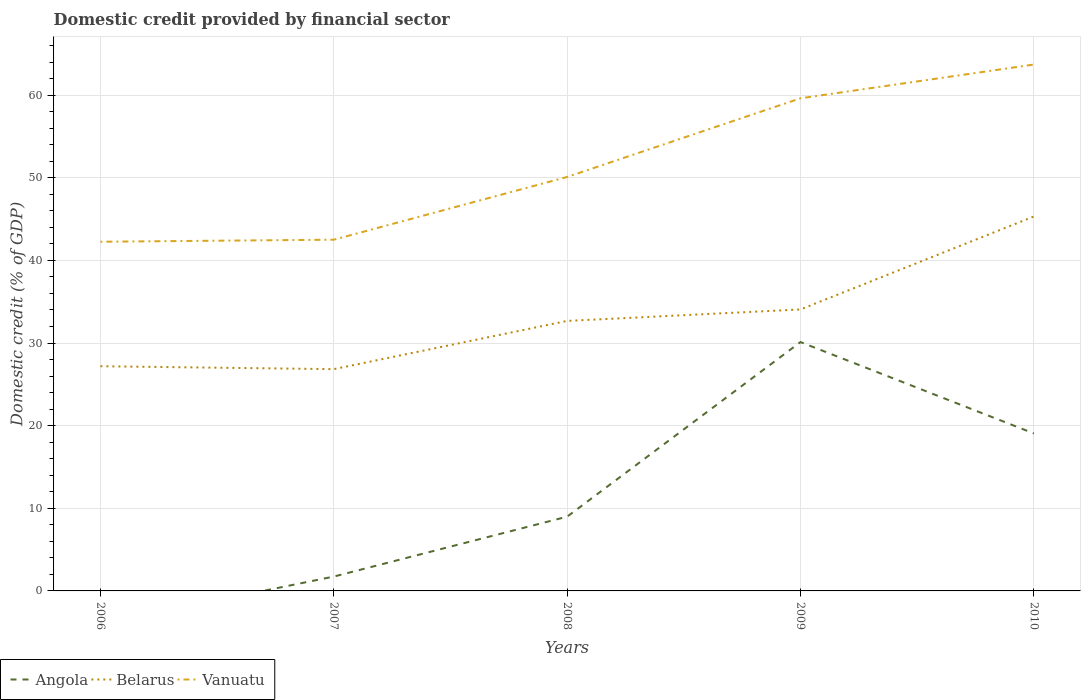How many different coloured lines are there?
Provide a short and direct response. 3. Does the line corresponding to Vanuatu intersect with the line corresponding to Belarus?
Your answer should be very brief. No. Is the number of lines equal to the number of legend labels?
Your answer should be compact. No. Across all years, what is the maximum domestic credit in Belarus?
Your answer should be compact. 26.84. What is the total domestic credit in Belarus in the graph?
Make the answer very short. -5.84. What is the difference between the highest and the second highest domestic credit in Vanuatu?
Keep it short and to the point. 21.44. How many years are there in the graph?
Ensure brevity in your answer.  5. Are the values on the major ticks of Y-axis written in scientific E-notation?
Provide a succinct answer. No. Does the graph contain grids?
Keep it short and to the point. Yes. Where does the legend appear in the graph?
Ensure brevity in your answer.  Bottom left. How many legend labels are there?
Your answer should be very brief. 3. How are the legend labels stacked?
Offer a very short reply. Horizontal. What is the title of the graph?
Offer a terse response. Domestic credit provided by financial sector. Does "OECD members" appear as one of the legend labels in the graph?
Ensure brevity in your answer.  No. What is the label or title of the Y-axis?
Offer a terse response. Domestic credit (% of GDP). What is the Domestic credit (% of GDP) in Belarus in 2006?
Offer a very short reply. 27.19. What is the Domestic credit (% of GDP) in Vanuatu in 2006?
Provide a succinct answer. 42.26. What is the Domestic credit (% of GDP) of Angola in 2007?
Your response must be concise. 1.74. What is the Domestic credit (% of GDP) in Belarus in 2007?
Ensure brevity in your answer.  26.84. What is the Domestic credit (% of GDP) in Vanuatu in 2007?
Your answer should be very brief. 42.5. What is the Domestic credit (% of GDP) in Angola in 2008?
Provide a short and direct response. 8.98. What is the Domestic credit (% of GDP) of Belarus in 2008?
Give a very brief answer. 32.67. What is the Domestic credit (% of GDP) in Vanuatu in 2008?
Provide a succinct answer. 50.09. What is the Domestic credit (% of GDP) in Angola in 2009?
Provide a succinct answer. 30.12. What is the Domestic credit (% of GDP) in Belarus in 2009?
Offer a very short reply. 34.06. What is the Domestic credit (% of GDP) in Vanuatu in 2009?
Your answer should be very brief. 59.61. What is the Domestic credit (% of GDP) in Angola in 2010?
Your answer should be compact. 19.06. What is the Domestic credit (% of GDP) of Belarus in 2010?
Offer a very short reply. 45.31. What is the Domestic credit (% of GDP) in Vanuatu in 2010?
Provide a succinct answer. 63.7. Across all years, what is the maximum Domestic credit (% of GDP) in Angola?
Provide a short and direct response. 30.12. Across all years, what is the maximum Domestic credit (% of GDP) in Belarus?
Give a very brief answer. 45.31. Across all years, what is the maximum Domestic credit (% of GDP) of Vanuatu?
Give a very brief answer. 63.7. Across all years, what is the minimum Domestic credit (% of GDP) in Angola?
Your response must be concise. 0. Across all years, what is the minimum Domestic credit (% of GDP) in Belarus?
Offer a terse response. 26.84. Across all years, what is the minimum Domestic credit (% of GDP) of Vanuatu?
Provide a short and direct response. 42.26. What is the total Domestic credit (% of GDP) in Angola in the graph?
Your response must be concise. 59.89. What is the total Domestic credit (% of GDP) of Belarus in the graph?
Ensure brevity in your answer.  166.08. What is the total Domestic credit (% of GDP) in Vanuatu in the graph?
Offer a terse response. 258.17. What is the difference between the Domestic credit (% of GDP) in Belarus in 2006 and that in 2007?
Provide a succinct answer. 0.35. What is the difference between the Domestic credit (% of GDP) of Vanuatu in 2006 and that in 2007?
Ensure brevity in your answer.  -0.25. What is the difference between the Domestic credit (% of GDP) of Belarus in 2006 and that in 2008?
Provide a succinct answer. -5.48. What is the difference between the Domestic credit (% of GDP) of Vanuatu in 2006 and that in 2008?
Ensure brevity in your answer.  -7.84. What is the difference between the Domestic credit (% of GDP) of Belarus in 2006 and that in 2009?
Your answer should be compact. -6.87. What is the difference between the Domestic credit (% of GDP) of Vanuatu in 2006 and that in 2009?
Offer a terse response. -17.36. What is the difference between the Domestic credit (% of GDP) in Belarus in 2006 and that in 2010?
Your response must be concise. -18.12. What is the difference between the Domestic credit (% of GDP) of Vanuatu in 2006 and that in 2010?
Your answer should be very brief. -21.44. What is the difference between the Domestic credit (% of GDP) in Angola in 2007 and that in 2008?
Your response must be concise. -7.25. What is the difference between the Domestic credit (% of GDP) in Belarus in 2007 and that in 2008?
Provide a succinct answer. -5.84. What is the difference between the Domestic credit (% of GDP) of Vanuatu in 2007 and that in 2008?
Make the answer very short. -7.59. What is the difference between the Domestic credit (% of GDP) in Angola in 2007 and that in 2009?
Ensure brevity in your answer.  -28.38. What is the difference between the Domestic credit (% of GDP) of Belarus in 2007 and that in 2009?
Your answer should be compact. -7.23. What is the difference between the Domestic credit (% of GDP) of Vanuatu in 2007 and that in 2009?
Offer a very short reply. -17.11. What is the difference between the Domestic credit (% of GDP) of Angola in 2007 and that in 2010?
Make the answer very short. -17.32. What is the difference between the Domestic credit (% of GDP) in Belarus in 2007 and that in 2010?
Ensure brevity in your answer.  -18.47. What is the difference between the Domestic credit (% of GDP) of Vanuatu in 2007 and that in 2010?
Your answer should be compact. -21.2. What is the difference between the Domestic credit (% of GDP) in Angola in 2008 and that in 2009?
Keep it short and to the point. -21.13. What is the difference between the Domestic credit (% of GDP) of Belarus in 2008 and that in 2009?
Ensure brevity in your answer.  -1.39. What is the difference between the Domestic credit (% of GDP) of Vanuatu in 2008 and that in 2009?
Ensure brevity in your answer.  -9.52. What is the difference between the Domestic credit (% of GDP) of Angola in 2008 and that in 2010?
Your response must be concise. -10.07. What is the difference between the Domestic credit (% of GDP) in Belarus in 2008 and that in 2010?
Offer a terse response. -12.64. What is the difference between the Domestic credit (% of GDP) in Vanuatu in 2008 and that in 2010?
Your response must be concise. -13.61. What is the difference between the Domestic credit (% of GDP) in Angola in 2009 and that in 2010?
Offer a terse response. 11.06. What is the difference between the Domestic credit (% of GDP) of Belarus in 2009 and that in 2010?
Provide a succinct answer. -11.25. What is the difference between the Domestic credit (% of GDP) of Vanuatu in 2009 and that in 2010?
Give a very brief answer. -4.09. What is the difference between the Domestic credit (% of GDP) of Belarus in 2006 and the Domestic credit (% of GDP) of Vanuatu in 2007?
Keep it short and to the point. -15.31. What is the difference between the Domestic credit (% of GDP) of Belarus in 2006 and the Domestic credit (% of GDP) of Vanuatu in 2008?
Keep it short and to the point. -22.9. What is the difference between the Domestic credit (% of GDP) of Belarus in 2006 and the Domestic credit (% of GDP) of Vanuatu in 2009?
Offer a very short reply. -32.42. What is the difference between the Domestic credit (% of GDP) of Belarus in 2006 and the Domestic credit (% of GDP) of Vanuatu in 2010?
Ensure brevity in your answer.  -36.51. What is the difference between the Domestic credit (% of GDP) of Angola in 2007 and the Domestic credit (% of GDP) of Belarus in 2008?
Provide a short and direct response. -30.94. What is the difference between the Domestic credit (% of GDP) of Angola in 2007 and the Domestic credit (% of GDP) of Vanuatu in 2008?
Make the answer very short. -48.36. What is the difference between the Domestic credit (% of GDP) of Belarus in 2007 and the Domestic credit (% of GDP) of Vanuatu in 2008?
Provide a short and direct response. -23.26. What is the difference between the Domestic credit (% of GDP) of Angola in 2007 and the Domestic credit (% of GDP) of Belarus in 2009?
Your response must be concise. -32.33. What is the difference between the Domestic credit (% of GDP) of Angola in 2007 and the Domestic credit (% of GDP) of Vanuatu in 2009?
Make the answer very short. -57.88. What is the difference between the Domestic credit (% of GDP) in Belarus in 2007 and the Domestic credit (% of GDP) in Vanuatu in 2009?
Your response must be concise. -32.78. What is the difference between the Domestic credit (% of GDP) of Angola in 2007 and the Domestic credit (% of GDP) of Belarus in 2010?
Ensure brevity in your answer.  -43.58. What is the difference between the Domestic credit (% of GDP) of Angola in 2007 and the Domestic credit (% of GDP) of Vanuatu in 2010?
Offer a terse response. -61.97. What is the difference between the Domestic credit (% of GDP) of Belarus in 2007 and the Domestic credit (% of GDP) of Vanuatu in 2010?
Provide a short and direct response. -36.86. What is the difference between the Domestic credit (% of GDP) in Angola in 2008 and the Domestic credit (% of GDP) in Belarus in 2009?
Your answer should be very brief. -25.08. What is the difference between the Domestic credit (% of GDP) in Angola in 2008 and the Domestic credit (% of GDP) in Vanuatu in 2009?
Your answer should be very brief. -50.63. What is the difference between the Domestic credit (% of GDP) of Belarus in 2008 and the Domestic credit (% of GDP) of Vanuatu in 2009?
Offer a terse response. -26.94. What is the difference between the Domestic credit (% of GDP) of Angola in 2008 and the Domestic credit (% of GDP) of Belarus in 2010?
Ensure brevity in your answer.  -36.33. What is the difference between the Domestic credit (% of GDP) in Angola in 2008 and the Domestic credit (% of GDP) in Vanuatu in 2010?
Your response must be concise. -54.72. What is the difference between the Domestic credit (% of GDP) of Belarus in 2008 and the Domestic credit (% of GDP) of Vanuatu in 2010?
Keep it short and to the point. -31.03. What is the difference between the Domestic credit (% of GDP) of Angola in 2009 and the Domestic credit (% of GDP) of Belarus in 2010?
Give a very brief answer. -15.2. What is the difference between the Domestic credit (% of GDP) of Angola in 2009 and the Domestic credit (% of GDP) of Vanuatu in 2010?
Make the answer very short. -33.58. What is the difference between the Domestic credit (% of GDP) in Belarus in 2009 and the Domestic credit (% of GDP) in Vanuatu in 2010?
Offer a terse response. -29.64. What is the average Domestic credit (% of GDP) of Angola per year?
Your answer should be compact. 11.98. What is the average Domestic credit (% of GDP) in Belarus per year?
Keep it short and to the point. 33.22. What is the average Domestic credit (% of GDP) in Vanuatu per year?
Give a very brief answer. 51.63. In the year 2006, what is the difference between the Domestic credit (% of GDP) of Belarus and Domestic credit (% of GDP) of Vanuatu?
Your answer should be compact. -15.07. In the year 2007, what is the difference between the Domestic credit (% of GDP) in Angola and Domestic credit (% of GDP) in Belarus?
Provide a short and direct response. -25.1. In the year 2007, what is the difference between the Domestic credit (% of GDP) in Angola and Domestic credit (% of GDP) in Vanuatu?
Provide a short and direct response. -40.77. In the year 2007, what is the difference between the Domestic credit (% of GDP) in Belarus and Domestic credit (% of GDP) in Vanuatu?
Ensure brevity in your answer.  -15.67. In the year 2008, what is the difference between the Domestic credit (% of GDP) in Angola and Domestic credit (% of GDP) in Belarus?
Your answer should be very brief. -23.69. In the year 2008, what is the difference between the Domestic credit (% of GDP) in Angola and Domestic credit (% of GDP) in Vanuatu?
Your response must be concise. -41.11. In the year 2008, what is the difference between the Domestic credit (% of GDP) of Belarus and Domestic credit (% of GDP) of Vanuatu?
Make the answer very short. -17.42. In the year 2009, what is the difference between the Domestic credit (% of GDP) of Angola and Domestic credit (% of GDP) of Belarus?
Keep it short and to the point. -3.95. In the year 2009, what is the difference between the Domestic credit (% of GDP) of Angola and Domestic credit (% of GDP) of Vanuatu?
Your answer should be compact. -29.5. In the year 2009, what is the difference between the Domestic credit (% of GDP) of Belarus and Domestic credit (% of GDP) of Vanuatu?
Your response must be concise. -25.55. In the year 2010, what is the difference between the Domestic credit (% of GDP) in Angola and Domestic credit (% of GDP) in Belarus?
Offer a very short reply. -26.25. In the year 2010, what is the difference between the Domestic credit (% of GDP) of Angola and Domestic credit (% of GDP) of Vanuatu?
Keep it short and to the point. -44.64. In the year 2010, what is the difference between the Domestic credit (% of GDP) in Belarus and Domestic credit (% of GDP) in Vanuatu?
Your answer should be very brief. -18.39. What is the ratio of the Domestic credit (% of GDP) of Belarus in 2006 to that in 2007?
Your answer should be very brief. 1.01. What is the ratio of the Domestic credit (% of GDP) in Belarus in 2006 to that in 2008?
Provide a short and direct response. 0.83. What is the ratio of the Domestic credit (% of GDP) of Vanuatu in 2006 to that in 2008?
Your response must be concise. 0.84. What is the ratio of the Domestic credit (% of GDP) in Belarus in 2006 to that in 2009?
Ensure brevity in your answer.  0.8. What is the ratio of the Domestic credit (% of GDP) of Vanuatu in 2006 to that in 2009?
Your answer should be compact. 0.71. What is the ratio of the Domestic credit (% of GDP) of Belarus in 2006 to that in 2010?
Provide a succinct answer. 0.6. What is the ratio of the Domestic credit (% of GDP) of Vanuatu in 2006 to that in 2010?
Provide a short and direct response. 0.66. What is the ratio of the Domestic credit (% of GDP) of Angola in 2007 to that in 2008?
Make the answer very short. 0.19. What is the ratio of the Domestic credit (% of GDP) of Belarus in 2007 to that in 2008?
Your answer should be very brief. 0.82. What is the ratio of the Domestic credit (% of GDP) of Vanuatu in 2007 to that in 2008?
Ensure brevity in your answer.  0.85. What is the ratio of the Domestic credit (% of GDP) in Angola in 2007 to that in 2009?
Ensure brevity in your answer.  0.06. What is the ratio of the Domestic credit (% of GDP) of Belarus in 2007 to that in 2009?
Give a very brief answer. 0.79. What is the ratio of the Domestic credit (% of GDP) of Vanuatu in 2007 to that in 2009?
Offer a terse response. 0.71. What is the ratio of the Domestic credit (% of GDP) in Angola in 2007 to that in 2010?
Make the answer very short. 0.09. What is the ratio of the Domestic credit (% of GDP) in Belarus in 2007 to that in 2010?
Ensure brevity in your answer.  0.59. What is the ratio of the Domestic credit (% of GDP) in Vanuatu in 2007 to that in 2010?
Your response must be concise. 0.67. What is the ratio of the Domestic credit (% of GDP) of Angola in 2008 to that in 2009?
Provide a succinct answer. 0.3. What is the ratio of the Domestic credit (% of GDP) in Belarus in 2008 to that in 2009?
Offer a very short reply. 0.96. What is the ratio of the Domestic credit (% of GDP) in Vanuatu in 2008 to that in 2009?
Ensure brevity in your answer.  0.84. What is the ratio of the Domestic credit (% of GDP) of Angola in 2008 to that in 2010?
Make the answer very short. 0.47. What is the ratio of the Domestic credit (% of GDP) in Belarus in 2008 to that in 2010?
Keep it short and to the point. 0.72. What is the ratio of the Domestic credit (% of GDP) in Vanuatu in 2008 to that in 2010?
Make the answer very short. 0.79. What is the ratio of the Domestic credit (% of GDP) of Angola in 2009 to that in 2010?
Ensure brevity in your answer.  1.58. What is the ratio of the Domestic credit (% of GDP) of Belarus in 2009 to that in 2010?
Provide a succinct answer. 0.75. What is the ratio of the Domestic credit (% of GDP) in Vanuatu in 2009 to that in 2010?
Provide a succinct answer. 0.94. What is the difference between the highest and the second highest Domestic credit (% of GDP) in Angola?
Ensure brevity in your answer.  11.06. What is the difference between the highest and the second highest Domestic credit (% of GDP) of Belarus?
Give a very brief answer. 11.25. What is the difference between the highest and the second highest Domestic credit (% of GDP) of Vanuatu?
Provide a short and direct response. 4.09. What is the difference between the highest and the lowest Domestic credit (% of GDP) of Angola?
Your answer should be compact. 30.12. What is the difference between the highest and the lowest Domestic credit (% of GDP) of Belarus?
Ensure brevity in your answer.  18.47. What is the difference between the highest and the lowest Domestic credit (% of GDP) in Vanuatu?
Your answer should be very brief. 21.44. 